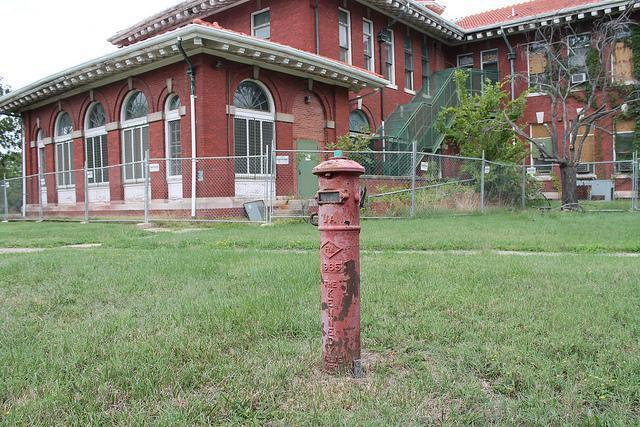How many fire hydrants are in the photo?
Give a very brief answer. 1. 